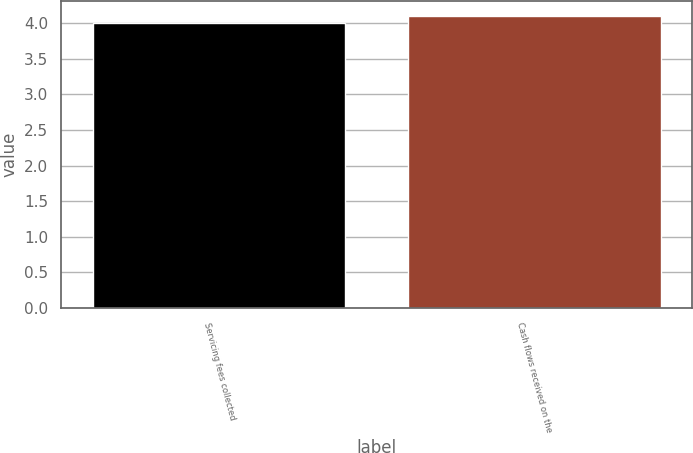Convert chart to OTSL. <chart><loc_0><loc_0><loc_500><loc_500><bar_chart><fcel>Servicing fees collected<fcel>Cash flows received on the<nl><fcel>4<fcel>4.1<nl></chart> 